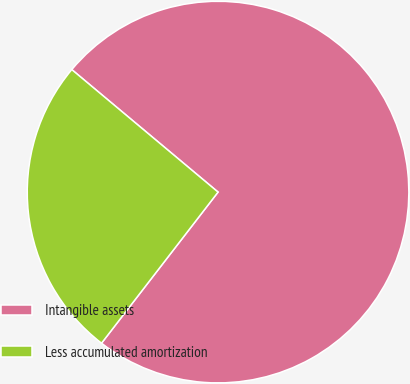<chart> <loc_0><loc_0><loc_500><loc_500><pie_chart><fcel>Intangible assets<fcel>Less accumulated amortization<nl><fcel>74.36%<fcel>25.64%<nl></chart> 